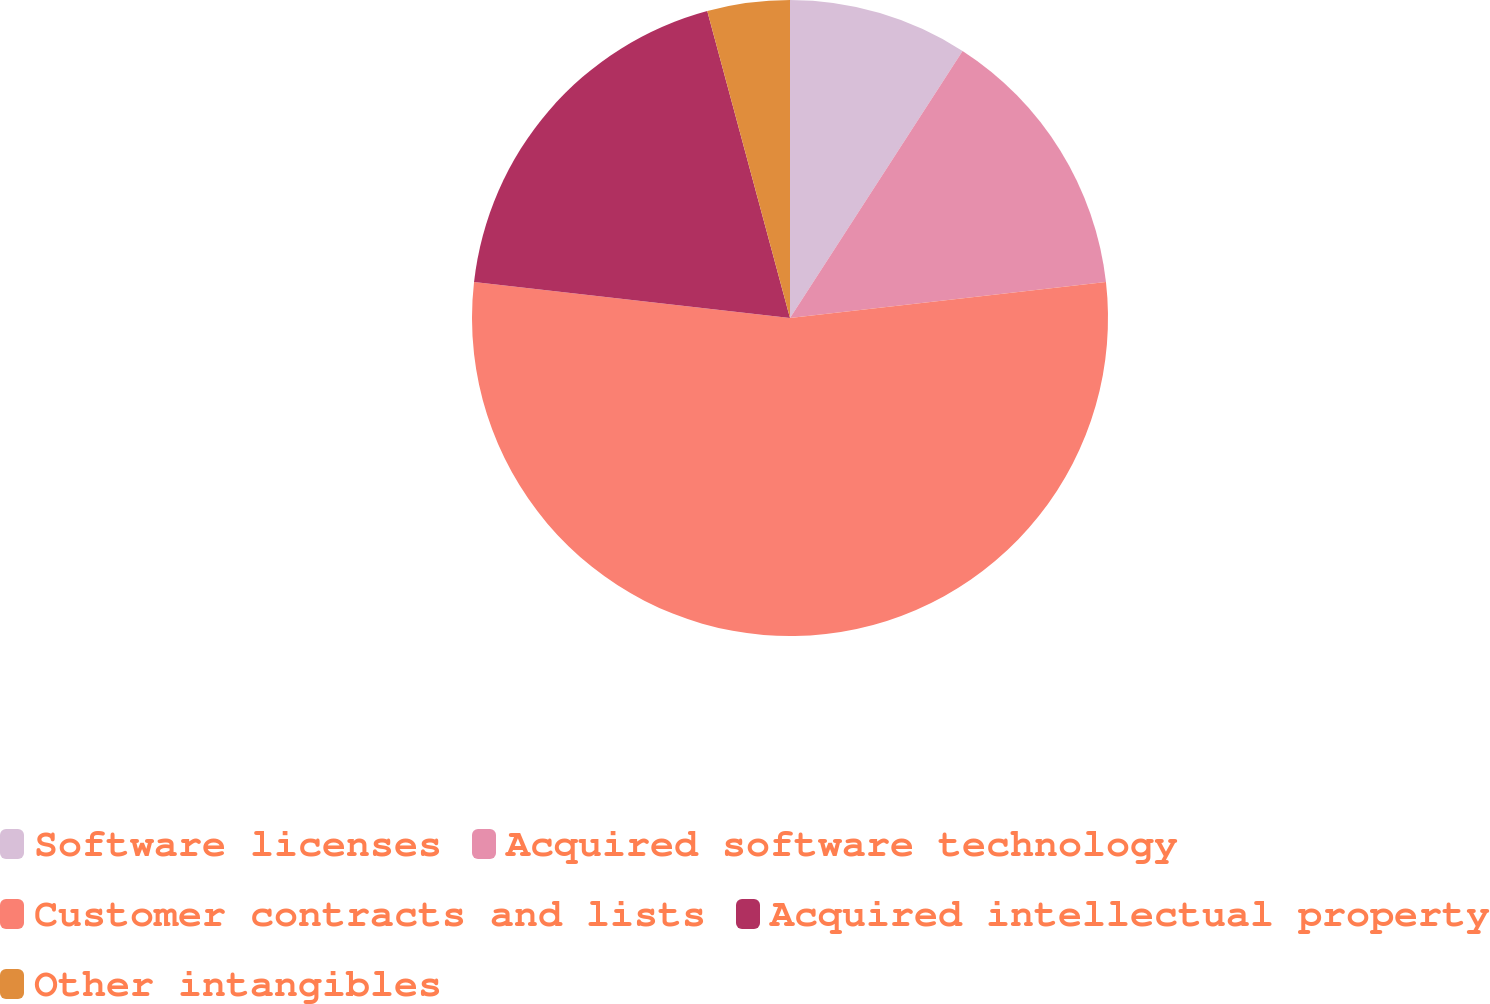<chart> <loc_0><loc_0><loc_500><loc_500><pie_chart><fcel>Software licenses<fcel>Acquired software technology<fcel>Customer contracts and lists<fcel>Acquired intellectual property<fcel>Other intangibles<nl><fcel>9.13%<fcel>14.07%<fcel>53.6%<fcel>19.01%<fcel>4.19%<nl></chart> 